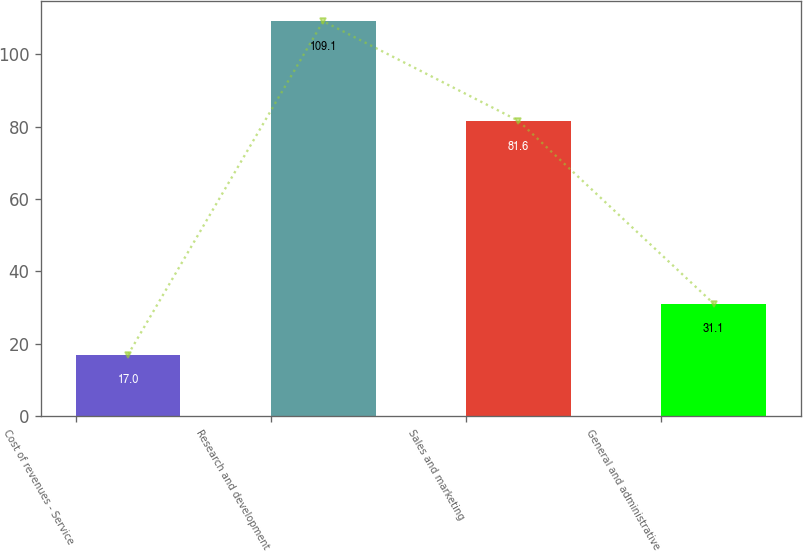<chart> <loc_0><loc_0><loc_500><loc_500><bar_chart><fcel>Cost of revenues - Service<fcel>Research and development<fcel>Sales and marketing<fcel>General and administrative<nl><fcel>17<fcel>109.1<fcel>81.6<fcel>31.1<nl></chart> 